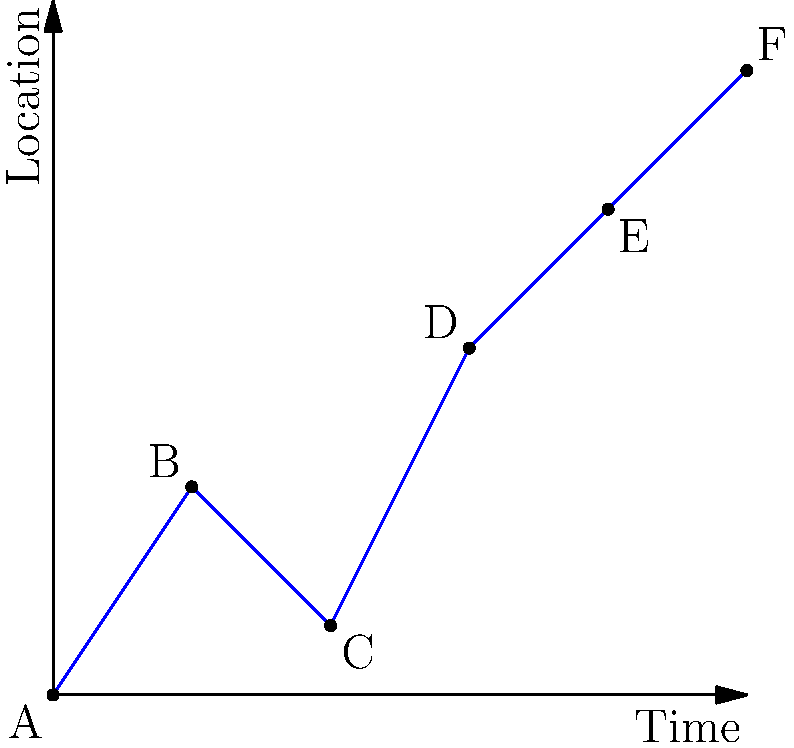In the "Half Bad" trilogy, Nathan's journey can be represented by the graph above, where the x-axis represents time and the y-axis represents his relative location (higher values indicate farther from his starting point). At which point does Nathan experience the most significant setback in his journey, and what is the magnitude of this setback? To answer this question, we need to analyze Nathan's journey as represented by the graph:

1. The graph shows Nathan's journey from point A to point F over time.
2. Each segment between points represents a part of his journey in the trilogy.
3. A setback is represented by a downward slope in the graph.
4. To find the most significant setback:
   a. Identify all downward slopes: There is only one, between points B and C.
   b. Calculate the magnitude of the setback:
      - B coordinates: (2, 3)
      - C coordinates: (4, 1)
      - Vertical distance: $3 - 1 = 2$
5. The magnitude of the setback is 2 units on the location axis.

Therefore, the most significant (and only) setback occurs between points B and C, with a magnitude of 2 units.
Answer: Between B and C; magnitude 2 